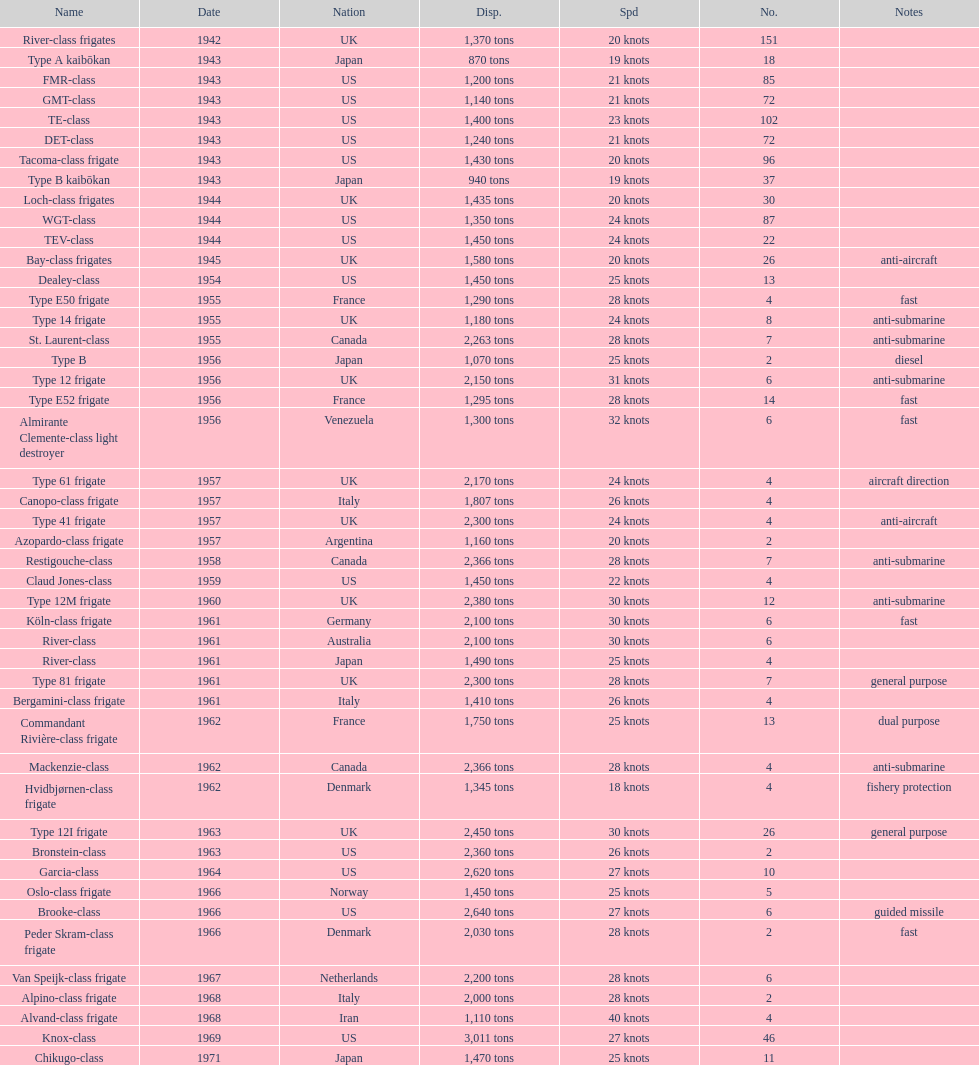In 1968 italy used alpino-class frigate. what was its top speed? 28 knots. 